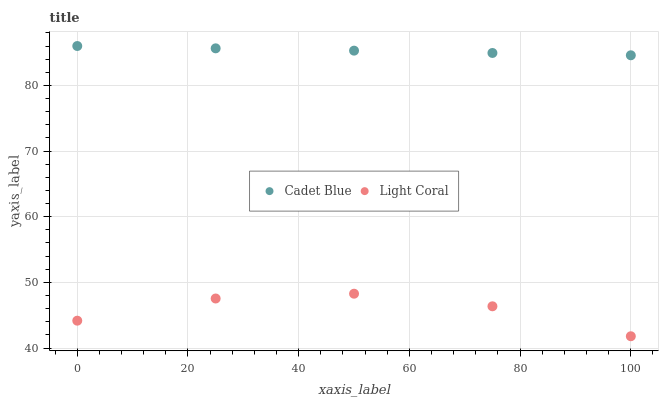Does Light Coral have the minimum area under the curve?
Answer yes or no. Yes. Does Cadet Blue have the maximum area under the curve?
Answer yes or no. Yes. Does Cadet Blue have the minimum area under the curve?
Answer yes or no. No. Is Cadet Blue the smoothest?
Answer yes or no. Yes. Is Light Coral the roughest?
Answer yes or no. Yes. Is Cadet Blue the roughest?
Answer yes or no. No. Does Light Coral have the lowest value?
Answer yes or no. Yes. Does Cadet Blue have the lowest value?
Answer yes or no. No. Does Cadet Blue have the highest value?
Answer yes or no. Yes. Is Light Coral less than Cadet Blue?
Answer yes or no. Yes. Is Cadet Blue greater than Light Coral?
Answer yes or no. Yes. Does Light Coral intersect Cadet Blue?
Answer yes or no. No. 